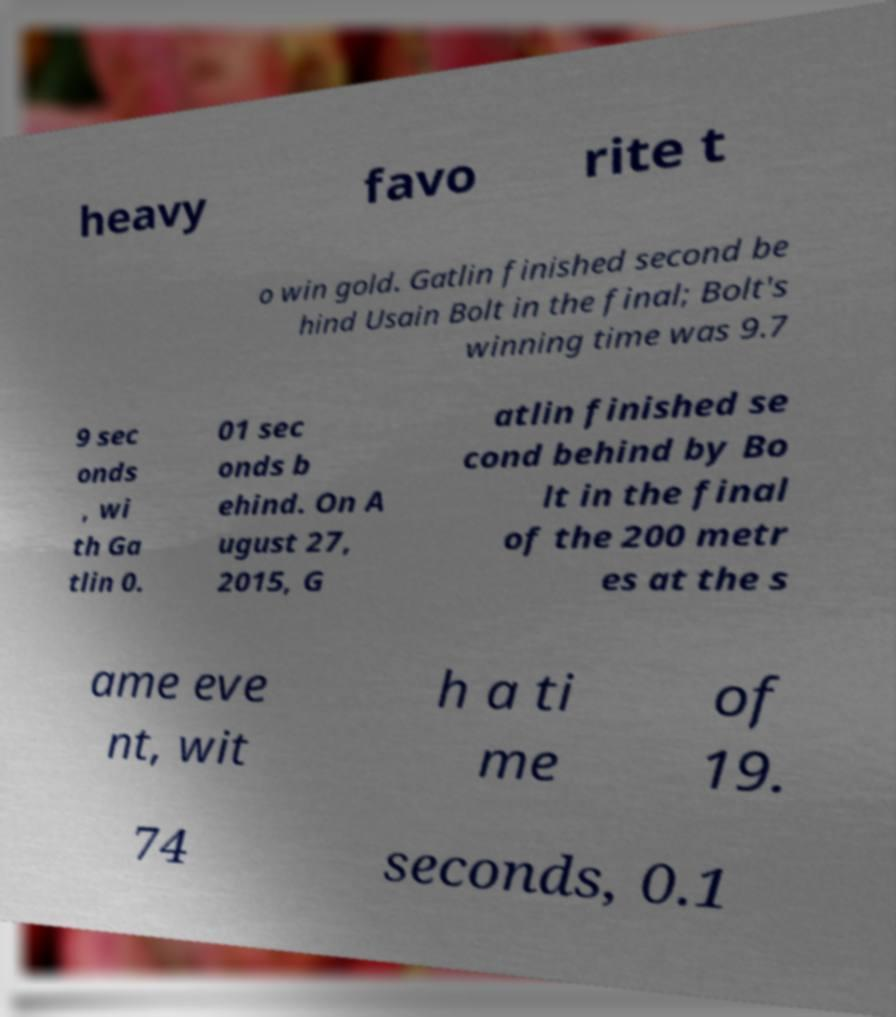What messages or text are displayed in this image? I need them in a readable, typed format. heavy favo rite t o win gold. Gatlin finished second be hind Usain Bolt in the final; Bolt's winning time was 9.7 9 sec onds , wi th Ga tlin 0. 01 sec onds b ehind. On A ugust 27, 2015, G atlin finished se cond behind by Bo lt in the final of the 200 metr es at the s ame eve nt, wit h a ti me of 19. 74 seconds, 0.1 